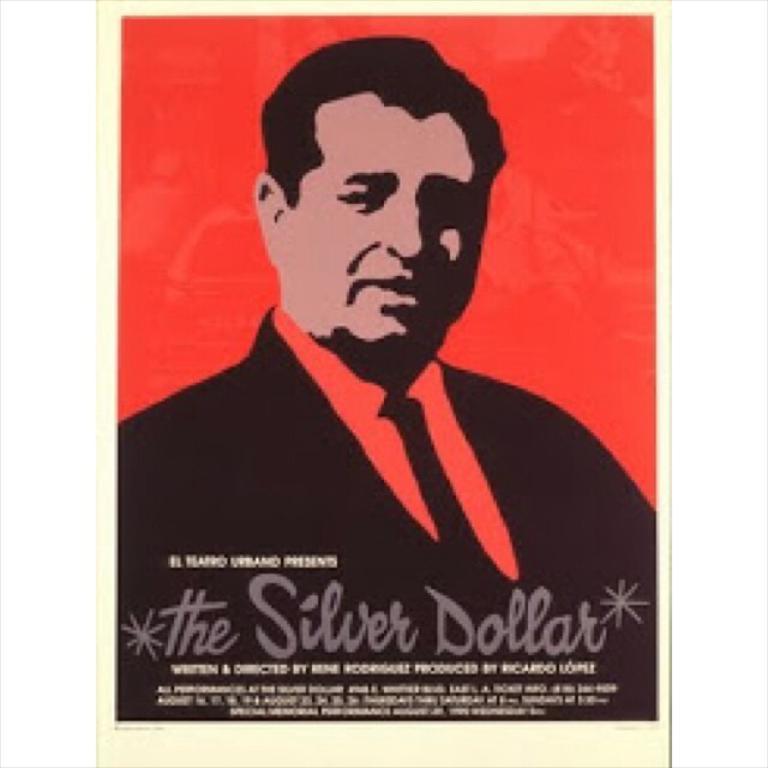Describe this image in one or two sentences. In this image I can see the person and something is written on it. Background is in red and cream color. 